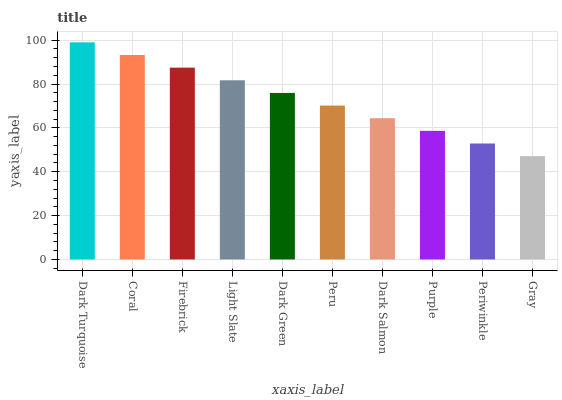Is Gray the minimum?
Answer yes or no. Yes. Is Dark Turquoise the maximum?
Answer yes or no. Yes. Is Coral the minimum?
Answer yes or no. No. Is Coral the maximum?
Answer yes or no. No. Is Dark Turquoise greater than Coral?
Answer yes or no. Yes. Is Coral less than Dark Turquoise?
Answer yes or no. Yes. Is Coral greater than Dark Turquoise?
Answer yes or no. No. Is Dark Turquoise less than Coral?
Answer yes or no. No. Is Dark Green the high median?
Answer yes or no. Yes. Is Peru the low median?
Answer yes or no. Yes. Is Dark Turquoise the high median?
Answer yes or no. No. Is Purple the low median?
Answer yes or no. No. 